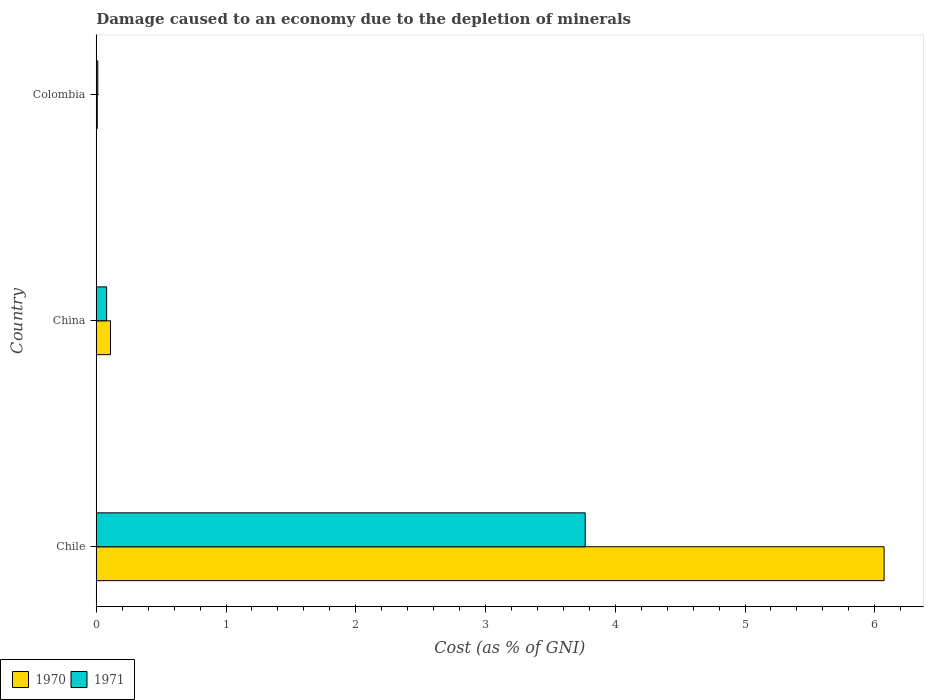How many different coloured bars are there?
Make the answer very short. 2. How many groups of bars are there?
Give a very brief answer. 3. How many bars are there on the 3rd tick from the top?
Your response must be concise. 2. How many bars are there on the 3rd tick from the bottom?
Give a very brief answer. 2. What is the label of the 3rd group of bars from the top?
Give a very brief answer. Chile. What is the cost of damage caused due to the depletion of minerals in 1970 in Colombia?
Offer a terse response. 0.01. Across all countries, what is the maximum cost of damage caused due to the depletion of minerals in 1970?
Ensure brevity in your answer.  6.07. Across all countries, what is the minimum cost of damage caused due to the depletion of minerals in 1971?
Your answer should be very brief. 0.01. In which country was the cost of damage caused due to the depletion of minerals in 1970 maximum?
Your answer should be compact. Chile. What is the total cost of damage caused due to the depletion of minerals in 1970 in the graph?
Give a very brief answer. 6.19. What is the difference between the cost of damage caused due to the depletion of minerals in 1970 in China and that in Colombia?
Your answer should be compact. 0.1. What is the difference between the cost of damage caused due to the depletion of minerals in 1971 in Chile and the cost of damage caused due to the depletion of minerals in 1970 in Colombia?
Offer a terse response. 3.76. What is the average cost of damage caused due to the depletion of minerals in 1970 per country?
Ensure brevity in your answer.  2.06. What is the difference between the cost of damage caused due to the depletion of minerals in 1971 and cost of damage caused due to the depletion of minerals in 1970 in Colombia?
Give a very brief answer. 0. In how many countries, is the cost of damage caused due to the depletion of minerals in 1971 greater than 3.4 %?
Your answer should be compact. 1. What is the ratio of the cost of damage caused due to the depletion of minerals in 1970 in China to that in Colombia?
Your answer should be very brief. 13.89. Is the cost of damage caused due to the depletion of minerals in 1971 in China less than that in Colombia?
Keep it short and to the point. No. What is the difference between the highest and the second highest cost of damage caused due to the depletion of minerals in 1971?
Offer a very short reply. 3.69. What is the difference between the highest and the lowest cost of damage caused due to the depletion of minerals in 1970?
Provide a short and direct response. 6.06. What does the 2nd bar from the top in Colombia represents?
Keep it short and to the point. 1970. What does the 2nd bar from the bottom in Colombia represents?
Your answer should be compact. 1971. How many bars are there?
Offer a terse response. 6. Are the values on the major ticks of X-axis written in scientific E-notation?
Your response must be concise. No. Does the graph contain any zero values?
Provide a succinct answer. No. Where does the legend appear in the graph?
Make the answer very short. Bottom left. What is the title of the graph?
Your answer should be very brief. Damage caused to an economy due to the depletion of minerals. What is the label or title of the X-axis?
Ensure brevity in your answer.  Cost (as % of GNI). What is the label or title of the Y-axis?
Your answer should be compact. Country. What is the Cost (as % of GNI) in 1970 in Chile?
Provide a short and direct response. 6.07. What is the Cost (as % of GNI) in 1971 in Chile?
Provide a succinct answer. 3.77. What is the Cost (as % of GNI) of 1970 in China?
Offer a terse response. 0.11. What is the Cost (as % of GNI) in 1971 in China?
Your answer should be compact. 0.08. What is the Cost (as % of GNI) of 1970 in Colombia?
Offer a terse response. 0.01. What is the Cost (as % of GNI) in 1971 in Colombia?
Provide a succinct answer. 0.01. Across all countries, what is the maximum Cost (as % of GNI) in 1970?
Provide a short and direct response. 6.07. Across all countries, what is the maximum Cost (as % of GNI) in 1971?
Keep it short and to the point. 3.77. Across all countries, what is the minimum Cost (as % of GNI) of 1970?
Your answer should be compact. 0.01. Across all countries, what is the minimum Cost (as % of GNI) in 1971?
Ensure brevity in your answer.  0.01. What is the total Cost (as % of GNI) of 1970 in the graph?
Give a very brief answer. 6.19. What is the total Cost (as % of GNI) of 1971 in the graph?
Provide a short and direct response. 3.86. What is the difference between the Cost (as % of GNI) of 1970 in Chile and that in China?
Ensure brevity in your answer.  5.96. What is the difference between the Cost (as % of GNI) in 1971 in Chile and that in China?
Keep it short and to the point. 3.69. What is the difference between the Cost (as % of GNI) in 1970 in Chile and that in Colombia?
Offer a terse response. 6.06. What is the difference between the Cost (as % of GNI) of 1971 in Chile and that in Colombia?
Provide a short and direct response. 3.76. What is the difference between the Cost (as % of GNI) in 1970 in China and that in Colombia?
Ensure brevity in your answer.  0.1. What is the difference between the Cost (as % of GNI) of 1971 in China and that in Colombia?
Your answer should be compact. 0.07. What is the difference between the Cost (as % of GNI) in 1970 in Chile and the Cost (as % of GNI) in 1971 in China?
Make the answer very short. 5.99. What is the difference between the Cost (as % of GNI) in 1970 in Chile and the Cost (as % of GNI) in 1971 in Colombia?
Keep it short and to the point. 6.06. What is the difference between the Cost (as % of GNI) of 1970 in China and the Cost (as % of GNI) of 1971 in Colombia?
Offer a very short reply. 0.1. What is the average Cost (as % of GNI) of 1970 per country?
Provide a short and direct response. 2.06. What is the average Cost (as % of GNI) in 1971 per country?
Keep it short and to the point. 1.29. What is the difference between the Cost (as % of GNI) in 1970 and Cost (as % of GNI) in 1971 in Chile?
Make the answer very short. 2.3. What is the difference between the Cost (as % of GNI) of 1970 and Cost (as % of GNI) of 1971 in China?
Your answer should be very brief. 0.03. What is the difference between the Cost (as % of GNI) of 1970 and Cost (as % of GNI) of 1971 in Colombia?
Ensure brevity in your answer.  -0. What is the ratio of the Cost (as % of GNI) of 1970 in Chile to that in China?
Your response must be concise. 55.21. What is the ratio of the Cost (as % of GNI) of 1971 in Chile to that in China?
Ensure brevity in your answer.  47.22. What is the ratio of the Cost (as % of GNI) of 1970 in Chile to that in Colombia?
Make the answer very short. 767.12. What is the ratio of the Cost (as % of GNI) in 1971 in Chile to that in Colombia?
Provide a short and direct response. 314.84. What is the ratio of the Cost (as % of GNI) in 1970 in China to that in Colombia?
Offer a very short reply. 13.89. What is the ratio of the Cost (as % of GNI) of 1971 in China to that in Colombia?
Ensure brevity in your answer.  6.67. What is the difference between the highest and the second highest Cost (as % of GNI) in 1970?
Provide a short and direct response. 5.96. What is the difference between the highest and the second highest Cost (as % of GNI) of 1971?
Provide a short and direct response. 3.69. What is the difference between the highest and the lowest Cost (as % of GNI) in 1970?
Provide a succinct answer. 6.06. What is the difference between the highest and the lowest Cost (as % of GNI) in 1971?
Your response must be concise. 3.76. 